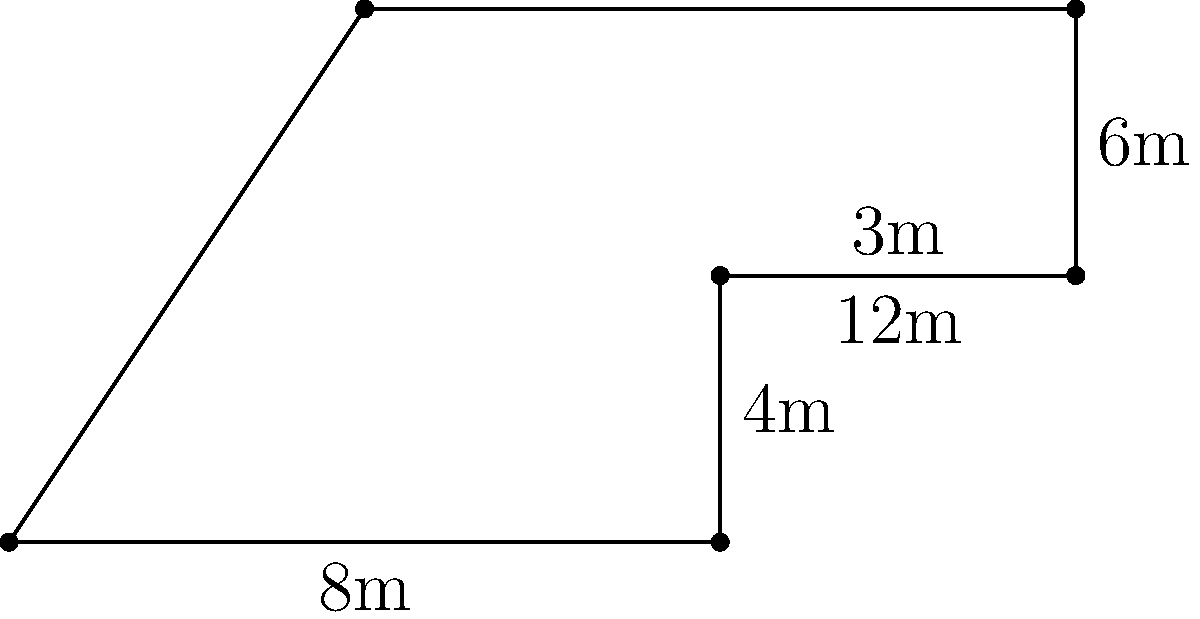An irregularly shaped boarding gate needs to be measured for a new flooring installation. The gate can be divided into a rectangle and a trapezoid as shown in the diagram. Calculate the total area of the boarding gate in square meters. To calculate the total area of the boarding gate, we need to find the areas of the rectangle and trapezoid separately, then add them together.

1. Area of the rectangle:
   Length = 8m, Width = 3m
   $A_{rectangle} = 8m \times 3m = 24m^2$

2. Area of the trapezoid:
   The formula for the area of a trapezoid is $A = \frac{1}{2}(b_1 + b_2)h$
   where $b_1$ and $b_2$ are the parallel sides and $h$ is the height.
   
   $b_1 = 12m$ (top side)
   $b_2 = 4m$ (bottom side)
   $h = 3m$ (height)
   
   $A_{trapezoid} = \frac{1}{2}(12m + 4m) \times 3m = \frac{1}{2} \times 16m \times 3m = 24m^2$

3. Total area:
   $A_{total} = A_{rectangle} + A_{trapezoid} = 24m^2 + 24m^2 = 48m^2$

Therefore, the total area of the boarding gate is 48 square meters.
Answer: $48m^2$ 